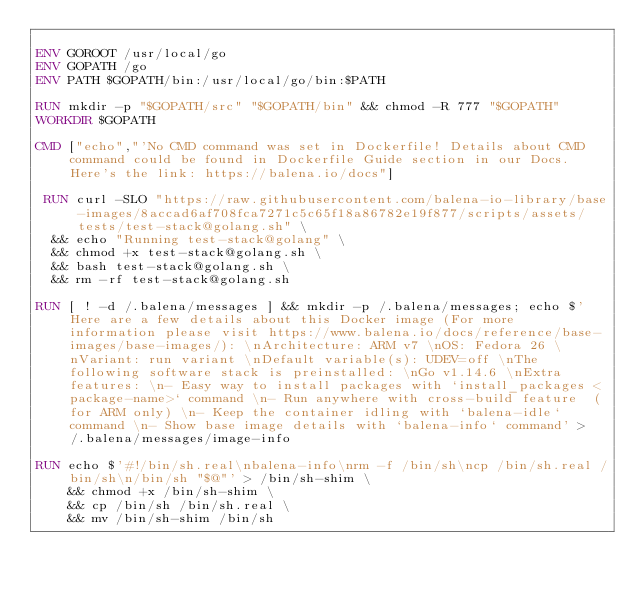<code> <loc_0><loc_0><loc_500><loc_500><_Dockerfile_>
ENV GOROOT /usr/local/go
ENV GOPATH /go
ENV PATH $GOPATH/bin:/usr/local/go/bin:$PATH

RUN mkdir -p "$GOPATH/src" "$GOPATH/bin" && chmod -R 777 "$GOPATH"
WORKDIR $GOPATH

CMD ["echo","'No CMD command was set in Dockerfile! Details about CMD command could be found in Dockerfile Guide section in our Docs. Here's the link: https://balena.io/docs"]

 RUN curl -SLO "https://raw.githubusercontent.com/balena-io-library/base-images/8accad6af708fca7271c5c65f18a86782e19f877/scripts/assets/tests/test-stack@golang.sh" \
  && echo "Running test-stack@golang" \
  && chmod +x test-stack@golang.sh \
  && bash test-stack@golang.sh \
  && rm -rf test-stack@golang.sh 

RUN [ ! -d /.balena/messages ] && mkdir -p /.balena/messages; echo $'Here are a few details about this Docker image (For more information please visit https://www.balena.io/docs/reference/base-images/base-images/): \nArchitecture: ARM v7 \nOS: Fedora 26 \nVariant: run variant \nDefault variable(s): UDEV=off \nThe following software stack is preinstalled: \nGo v1.14.6 \nExtra features: \n- Easy way to install packages with `install_packages <package-name>` command \n- Run anywhere with cross-build feature  (for ARM only) \n- Keep the container idling with `balena-idle` command \n- Show base image details with `balena-info` command' > /.balena/messages/image-info

RUN echo $'#!/bin/sh.real\nbalena-info\nrm -f /bin/sh\ncp /bin/sh.real /bin/sh\n/bin/sh "$@"' > /bin/sh-shim \
	&& chmod +x /bin/sh-shim \
	&& cp /bin/sh /bin/sh.real \
	&& mv /bin/sh-shim /bin/sh</code> 